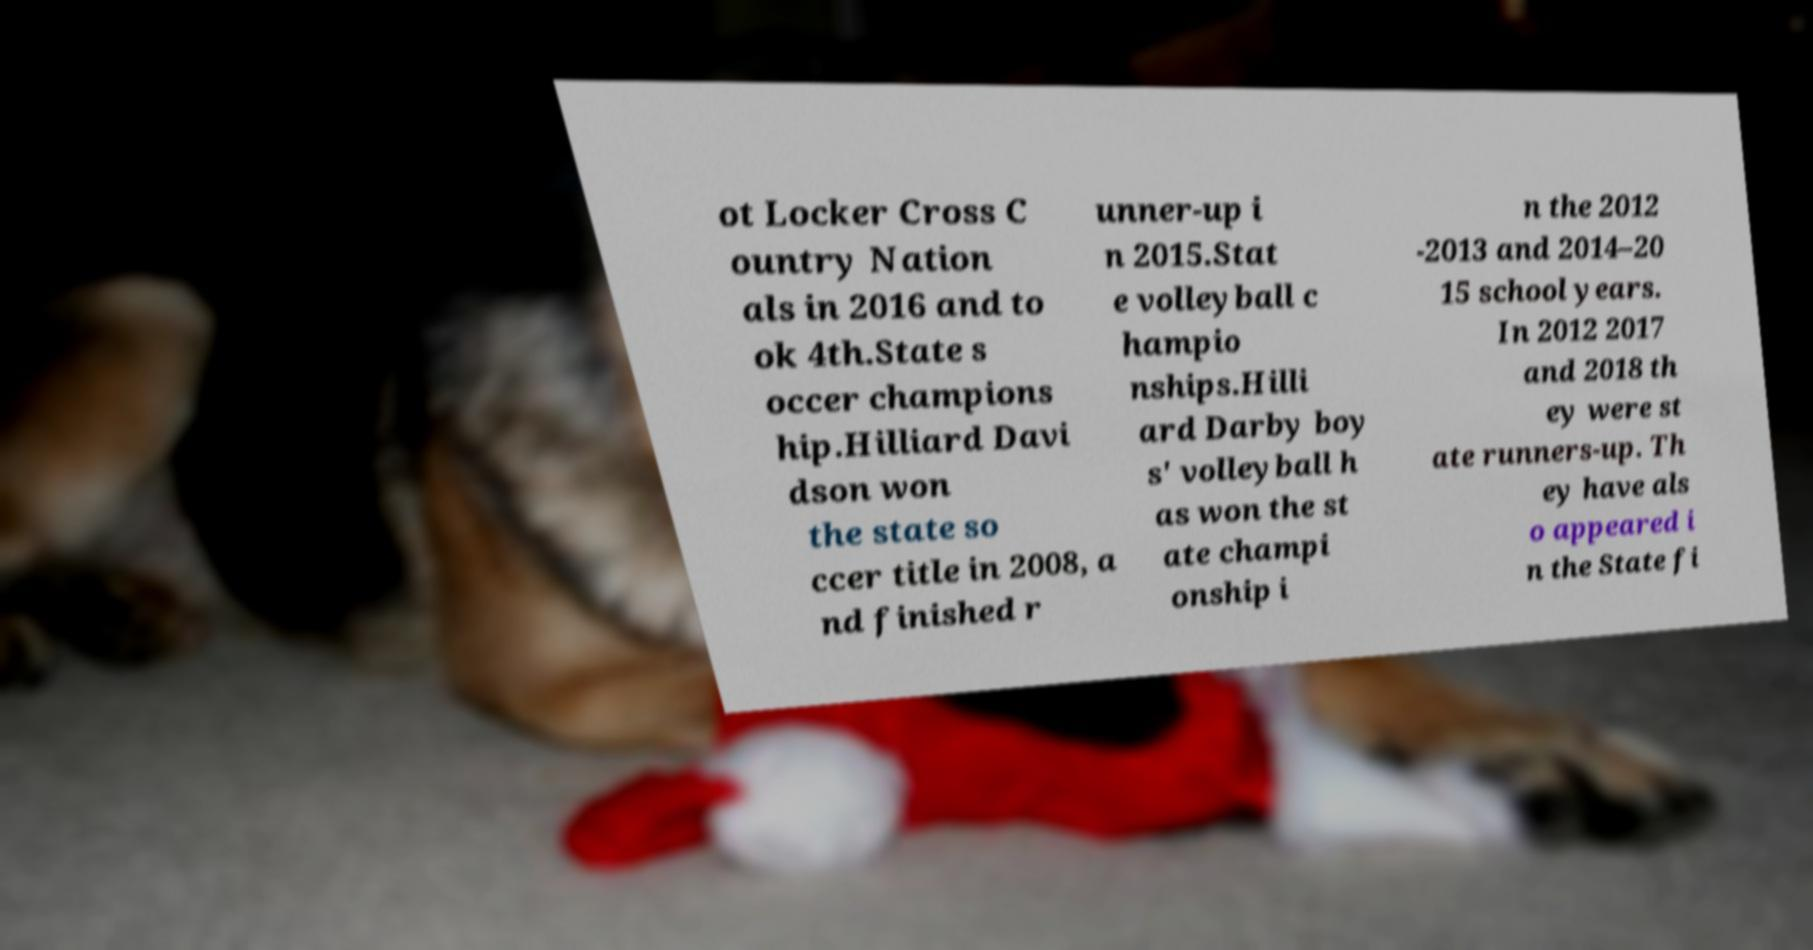Could you extract and type out the text from this image? ot Locker Cross C ountry Nation als in 2016 and to ok 4th.State s occer champions hip.Hilliard Davi dson won the state so ccer title in 2008, a nd finished r unner-up i n 2015.Stat e volleyball c hampio nships.Hilli ard Darby boy s' volleyball h as won the st ate champi onship i n the 2012 -2013 and 2014–20 15 school years. In 2012 2017 and 2018 th ey were st ate runners-up. Th ey have als o appeared i n the State fi 